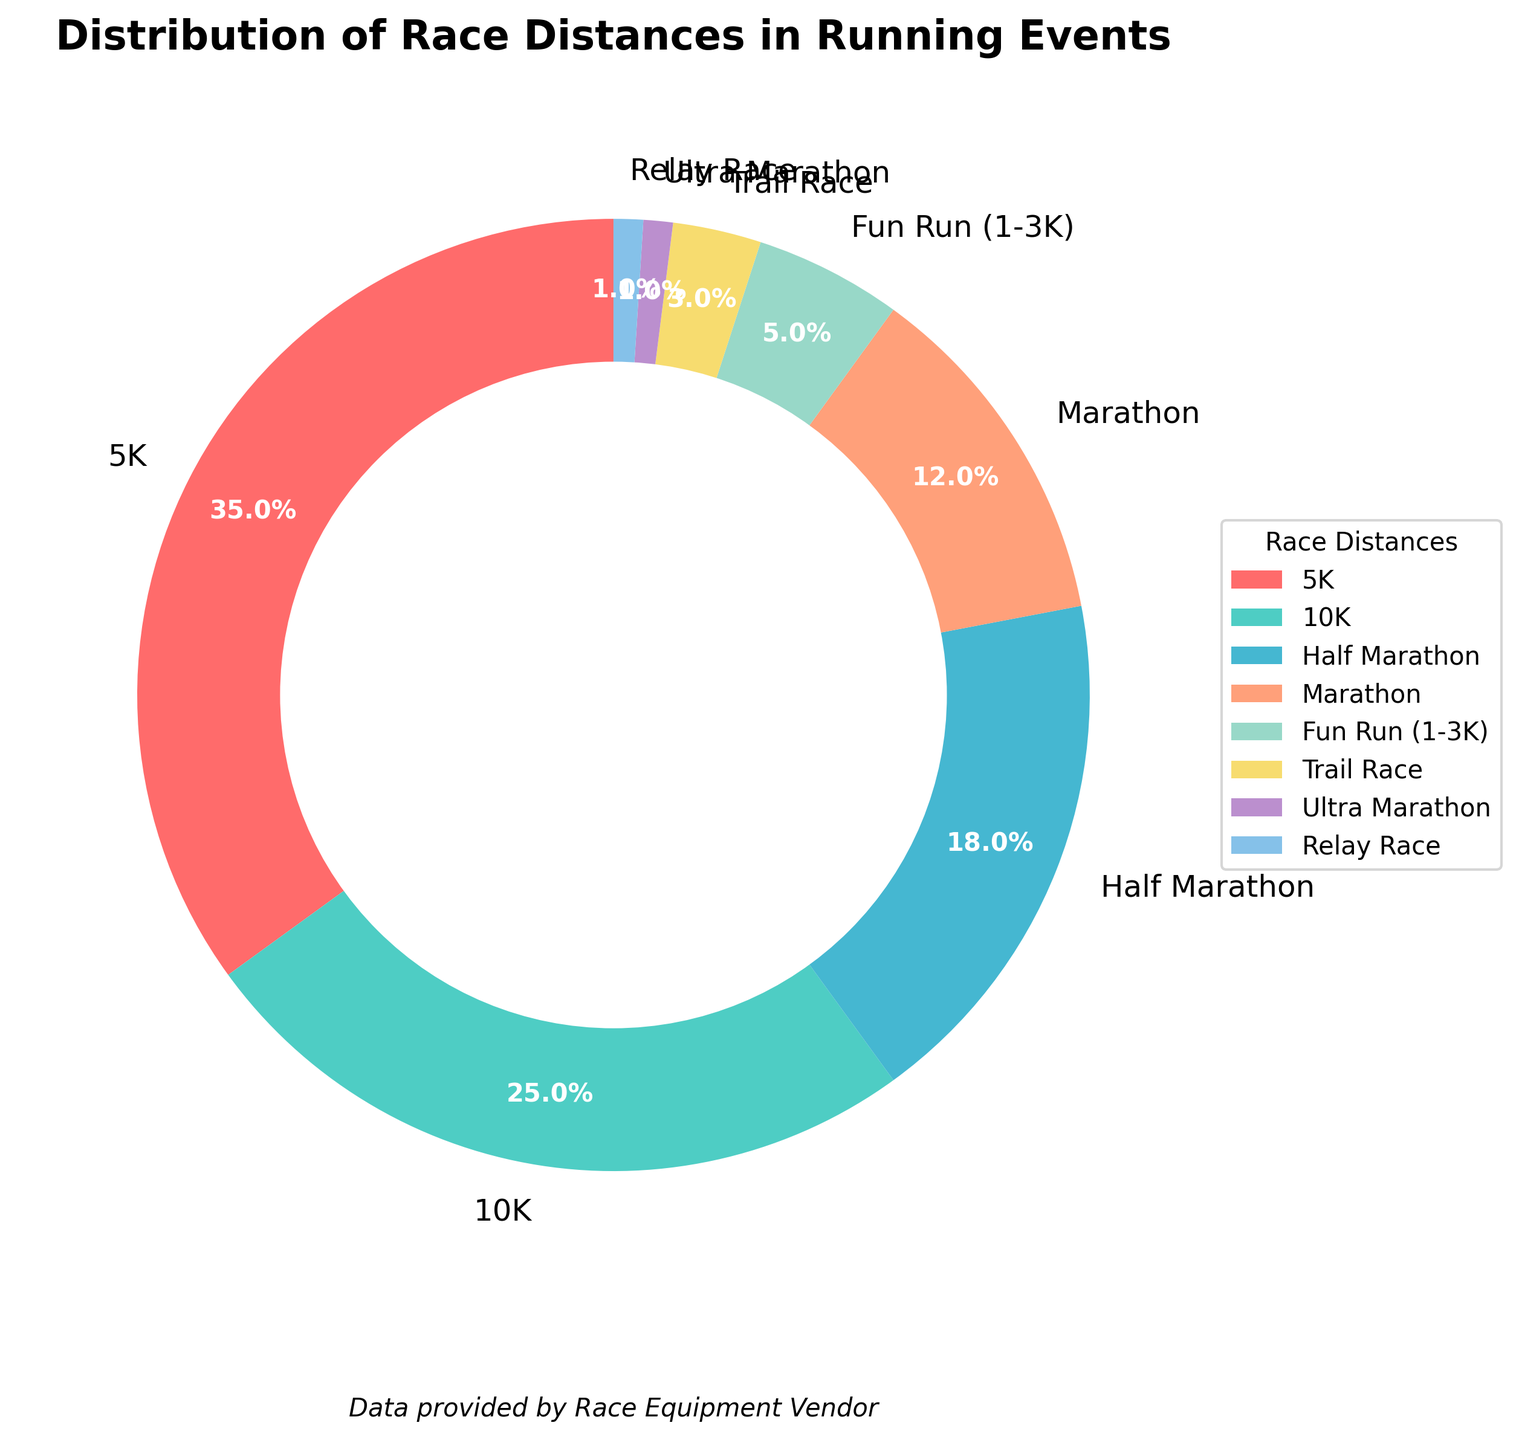Which race distance has the largest representation in running events? To answer this, look at the pie chart and identify the segment with the highest percentage label. The "5K" segment is the largest at 35%.
Answer: 5K What is the combined percentage of Half Marathon and Marathon races? Check the percentages for Half Marathon and Marathon in the pie chart, which are 18% and 12% respectively. Add these to get 18% + 12% = 30%.
Answer: 30% What race distance makes up the smallest portion of the running events? Look for the smallest segment in the pie chart. Both "Ultra Marathon" and "Relay Race" are shown as 1%, but they sum up to the same smallest value: 1%.
Answer: Ultra Marathon or Relay Race How much more popular is the 10K race compared to the Trail Race? Identify the percentages for 10K and Trail Race, which are 25% and 3% respectively, and calculate the difference: 25% - 3% = 22%.
Answer: 22% What proportion of the running events are less than a 10K? Look at the segments for distances less than 10K, which are Fun Run (1-3K) at 5% and 5K at 35%, and sum them up: 5% + 35% = 40%.
Answer: 40% What is the approximate percentage of all non-marathon distances combined? Sum the percentages of all distances except Half Marathon (18%) and Marathon (12%): 35% + 25% + 5% + 3% + 1% + 1% = 70%.
Answer: 70% Which color represents the Marathon distance in the pie chart? The Marathon segment can be visually identified by its color. In the chart, the Marathon is represented by an orange color.
Answer: Orange Is the percentage of Relay Races greater than, less than, or equal to the percentage of Ultra Marathons? Both Relay Races and Ultra Marathons are represented by 1% segments in the pie chart, making them equal.
Answer: Equal What is the percentage difference between the two most common race distances? The two most common distances are 5K at 35% and 10K at 25%. Calculate the difference: 35% - 25% = 10%.
Answer: 10% Identify which three race distances constitute the top 65% of running events? Look at the top three largest segments in the pie chart: 5K (35%), 10K (25%), and Half Marathon (18%). Verify cumulative percentage: 35% + 25% + 18% = 78%, but including the third distance completes a 78%, starting from 65%.
Answer: 5K, 10K, Half Marathon 